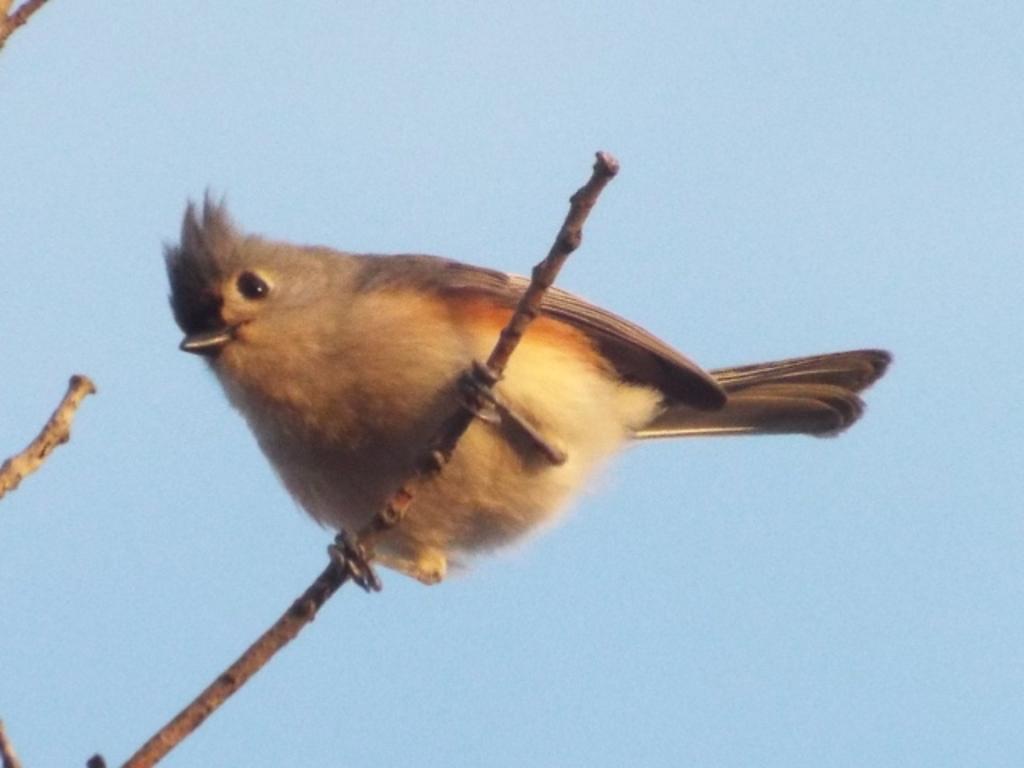How would you summarize this image in a sentence or two? In this image I can see a bird on the stick. The bird is in cream and brown color. In the background I can see the sky. 